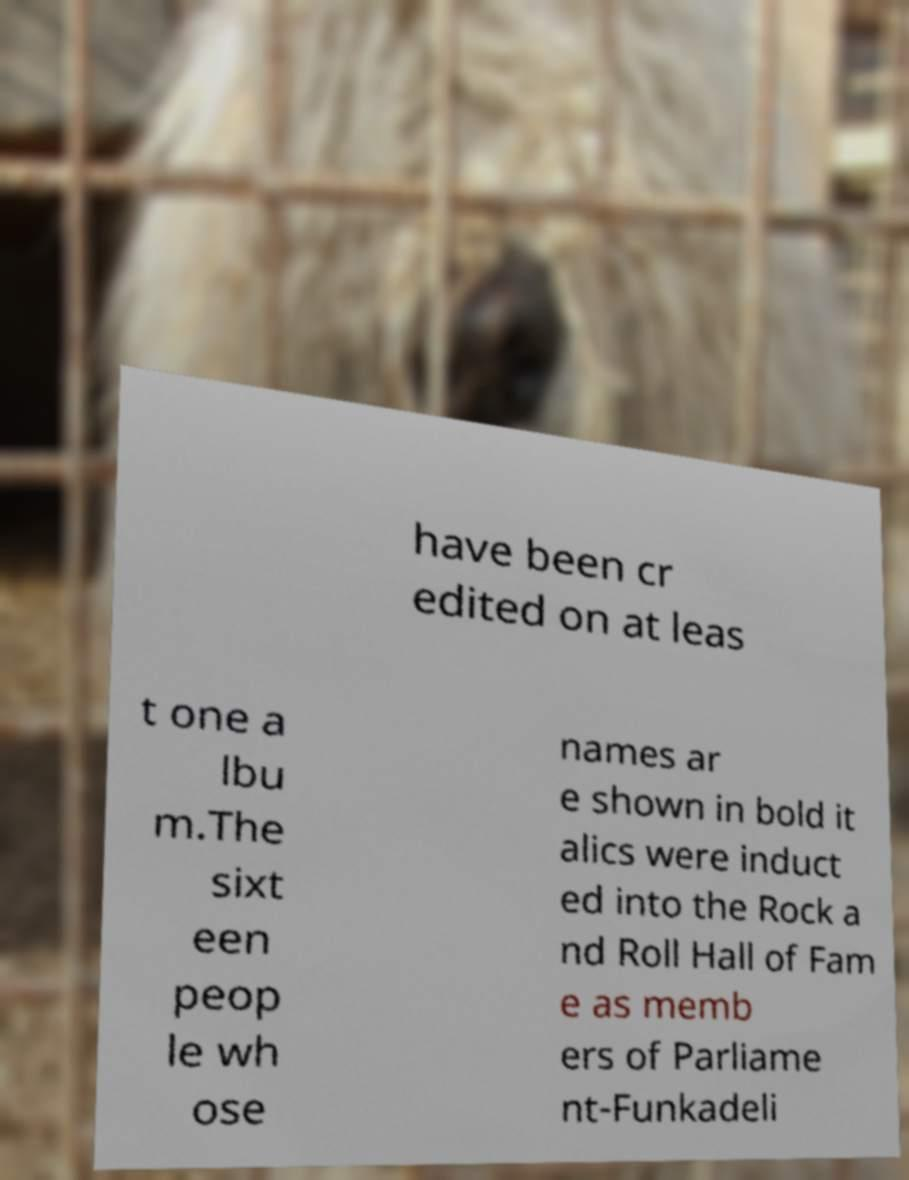Could you extract and type out the text from this image? have been cr edited on at leas t one a lbu m.The sixt een peop le wh ose names ar e shown in bold it alics were induct ed into the Rock a nd Roll Hall of Fam e as memb ers of Parliame nt-Funkadeli 